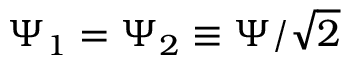Convert formula to latex. <formula><loc_0><loc_0><loc_500><loc_500>\Psi _ { 1 } = \Psi _ { 2 } \equiv \Psi / \sqrt { 2 }</formula> 